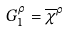Convert formula to latex. <formula><loc_0><loc_0><loc_500><loc_500>G _ { 1 } ^ { \rho } = \overline { \chi } ^ { \rho }</formula> 